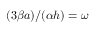<formula> <loc_0><loc_0><loc_500><loc_500>( 3 \beta a ) / ( \alpha h ) = \omega</formula> 